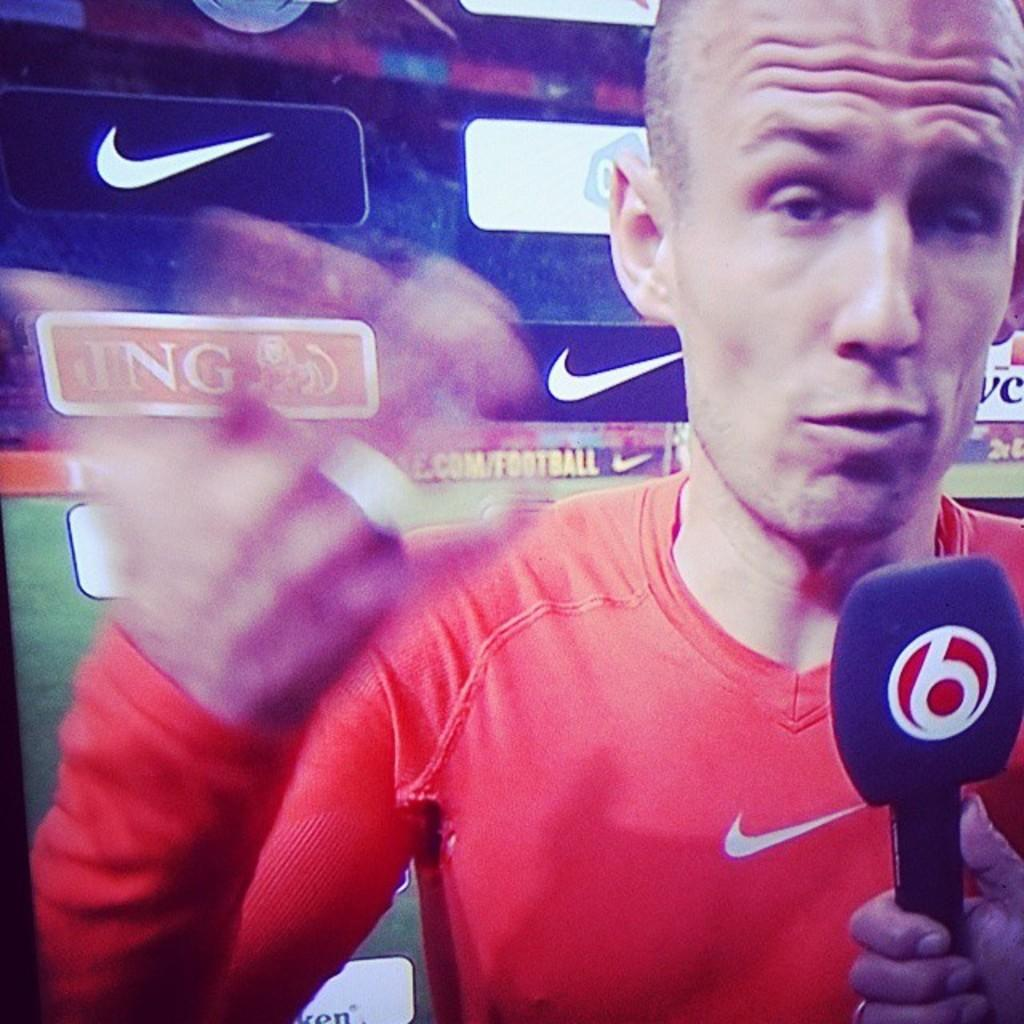What object is located in the bottom right of the image? There is a mic in the bottom right of the image. Who is holding the mic? A person is holding the mic. What is in front of the mic? There is a player in front of the mic. What can be seen behind the player? There is a sponsor board behind the player. What type of cushion is being used by the player in the image? There is no cushion visible in the image; the focus is on the mic, the person holding it, and the player in front of it. How many beans are present on the sponsor board in the image? There are no beans mentioned or visible on the sponsor board in the image. 